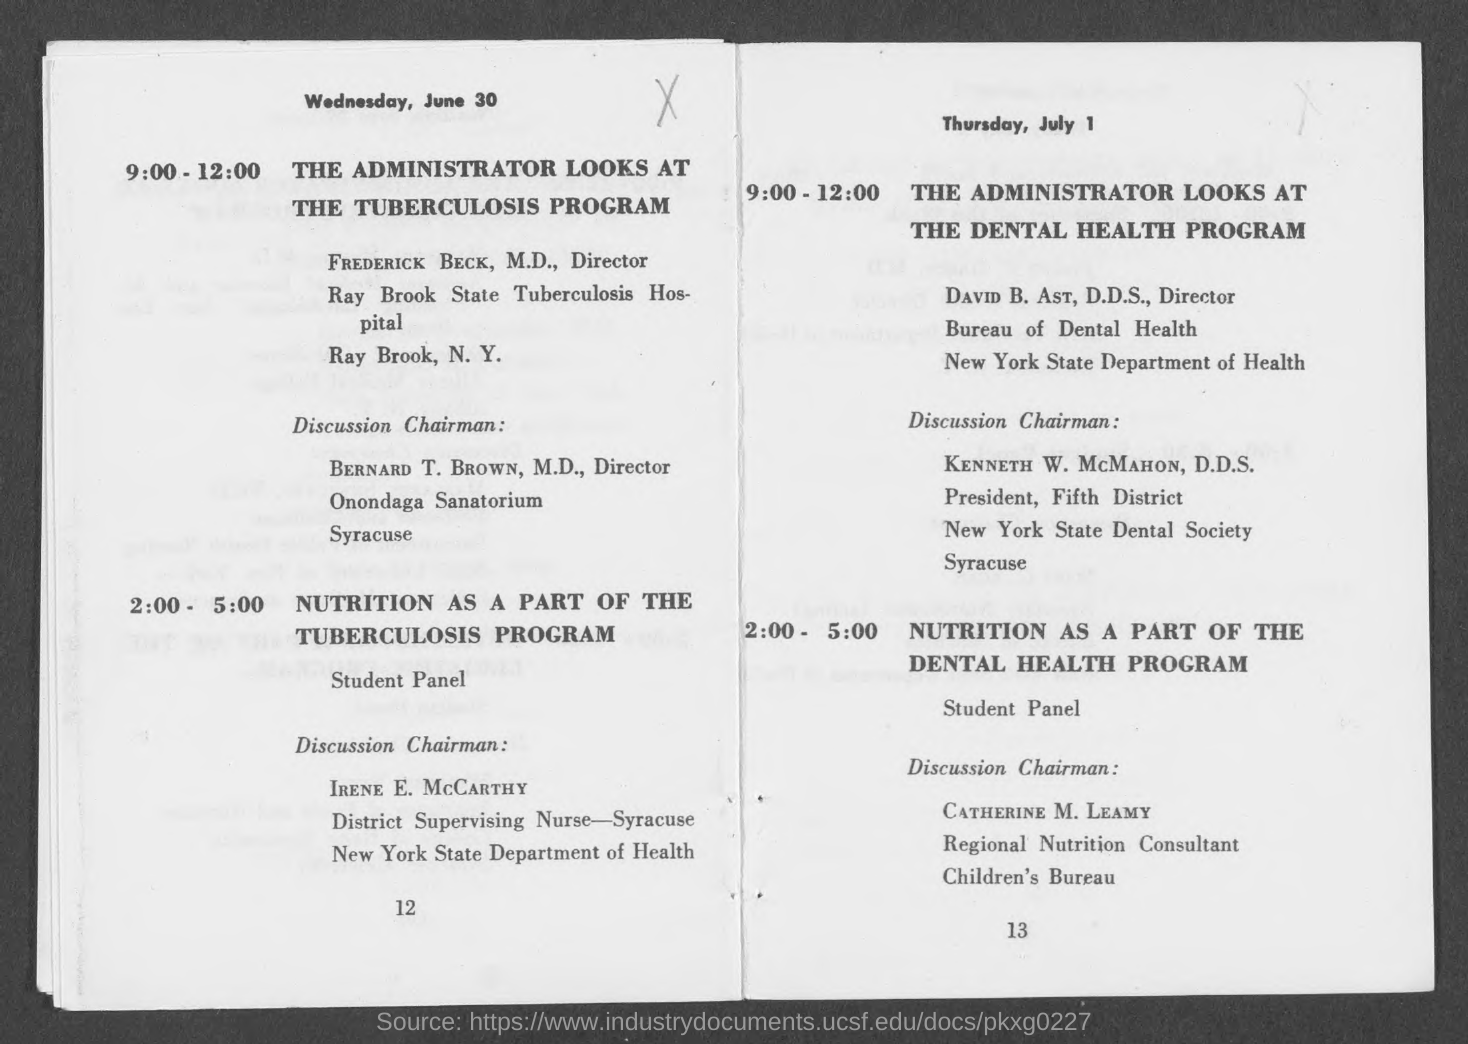What is the date mentioned on page 12?
Provide a short and direct response. Wednesday, june 30. What is the designation of bernard t. brown?
Your answer should be very brief. Director. Who is the discussion chairman for nutrition as a part of the tuberculosis program?
Provide a short and direct response. Irene e. mccarthy. 